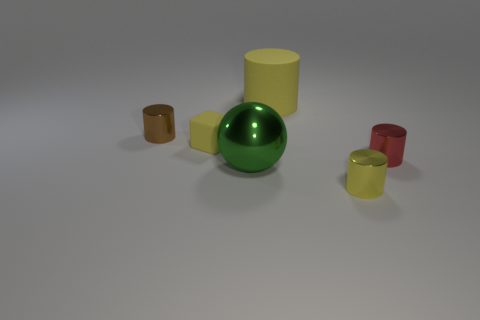Is there a small metal thing left of the large thing behind the red object?
Your answer should be compact. Yes. Is the number of big gray cylinders less than the number of brown cylinders?
Provide a succinct answer. Yes. What is the material of the small yellow thing that is on the right side of the yellow cylinder that is behind the tiny brown shiny thing?
Provide a succinct answer. Metal. Is the brown cylinder the same size as the red thing?
Provide a succinct answer. Yes. How many objects are small brown shiny cylinders or tiny objects?
Give a very brief answer. 4. What is the size of the yellow object that is both in front of the large rubber object and left of the tiny yellow metallic cylinder?
Offer a terse response. Small. Is the number of big yellow cylinders that are behind the big rubber cylinder less than the number of tiny purple matte cylinders?
Your response must be concise. No. There is a green object that is the same material as the red cylinder; what is its shape?
Ensure brevity in your answer.  Sphere. Do the yellow matte object in front of the rubber cylinder and the rubber thing that is behind the brown thing have the same shape?
Keep it short and to the point. No. Are there fewer yellow cubes that are right of the large metal sphere than tiny red metal objects behind the tiny brown thing?
Make the answer very short. No. 